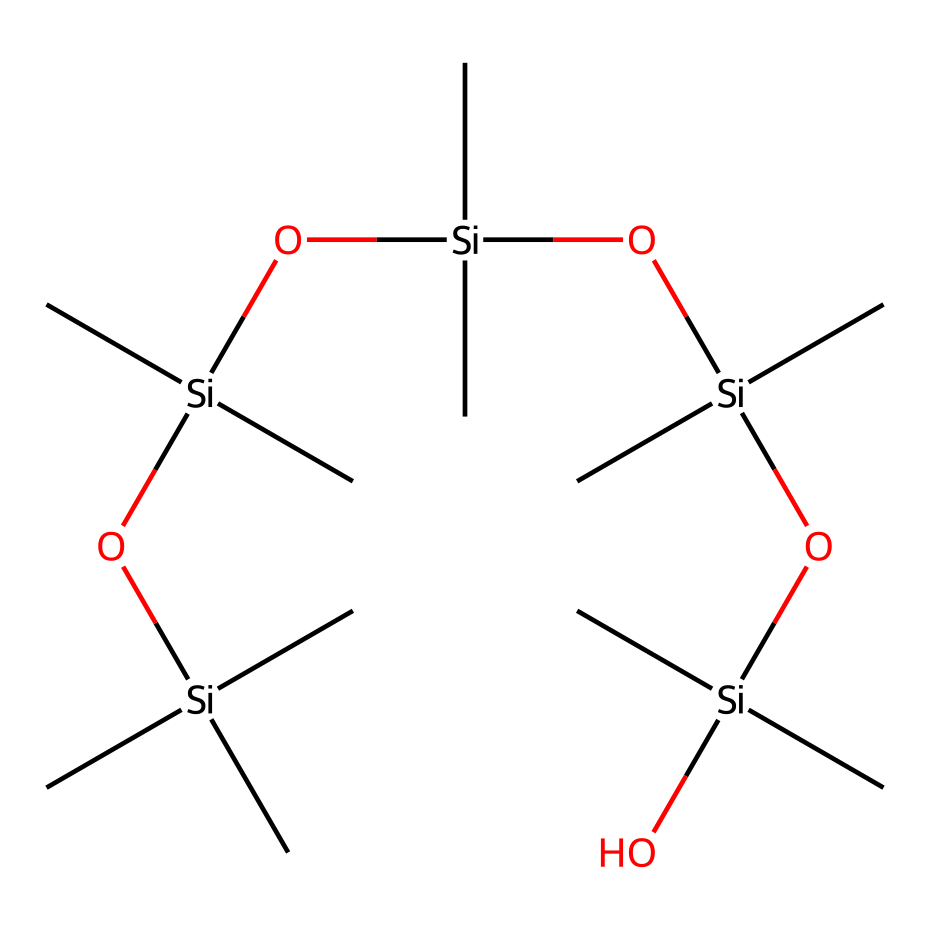how many silicon atoms are in the structure? The SMILES representation indicates that there are five instances of the silicon atom denoted by "Si". Each occurrence of "[Si]" represents a silicon atom.
Answer: five how many oxygen atoms are in the structure? The SMILES includes four occurrences of the oxygen atom represented by "O". Each time "O" appears indicates an oxygen atom.
Answer: four what is the degree of branching in this chemical? The chemical structure shows multiple carbon groups attached to each silicon atom. Each silicon atom has three methyl groups (C), indicating significant branching due to the presence of multiple substituents.
Answer: high what type of functional groups are present in this molecule? The molecule primarily features siloxane linkages (-Si-O-), which are characteristic of siloxanes, as well as methyl groups (-C).
Answer: siloxane which part of this chemical gives it a silicone property? The repeating siloxane units (-Si-O-) are responsible for its silicone properties, providing flexibility and moisture resistance typical of silicone compounds.
Answer: siloxane units what is the general nature of this substance (soluble or insoluble in water)? Siloxanes, especially those with many methyl groups, are generally hydrophobic and do not interact favorably with water, indicating that this compound is likely insoluble in water.
Answer: insoluble what is the significance of the methyl groups in this structure? The methyl groups contribute to the non-polar characteristics of the molecule, affecting its physical properties such as volatility, viscosity, and surface activity, which are all significant in personal care applications.
Answer: non-polar characteristics 